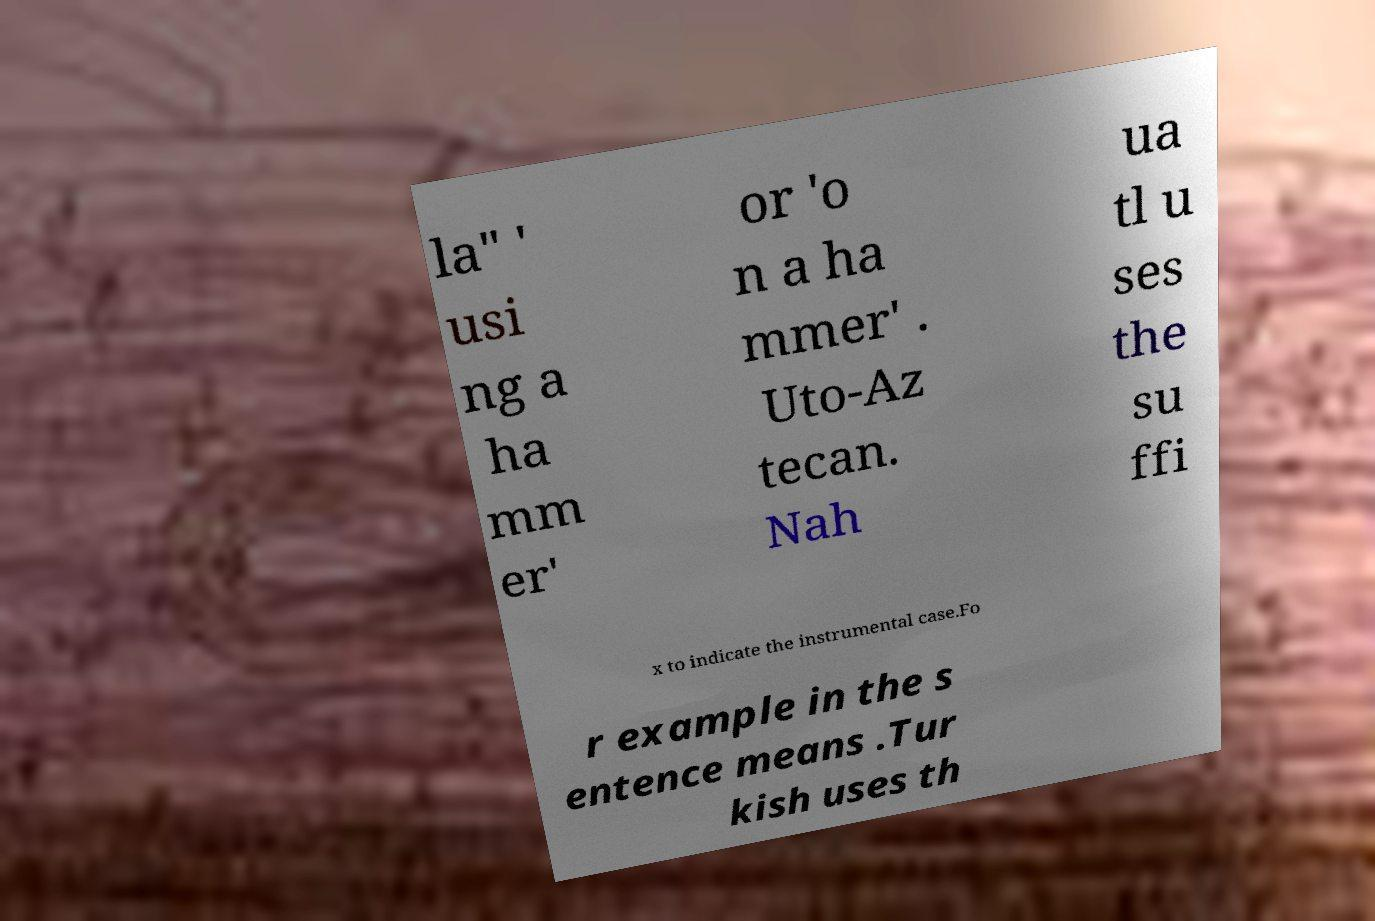Please read and relay the text visible in this image. What does it say? la" ' usi ng a ha mm er' or 'o n a ha mmer' . Uto-Az tecan. Nah ua tl u ses the su ffi x to indicate the instrumental case.Fo r example in the s entence means .Tur kish uses th 